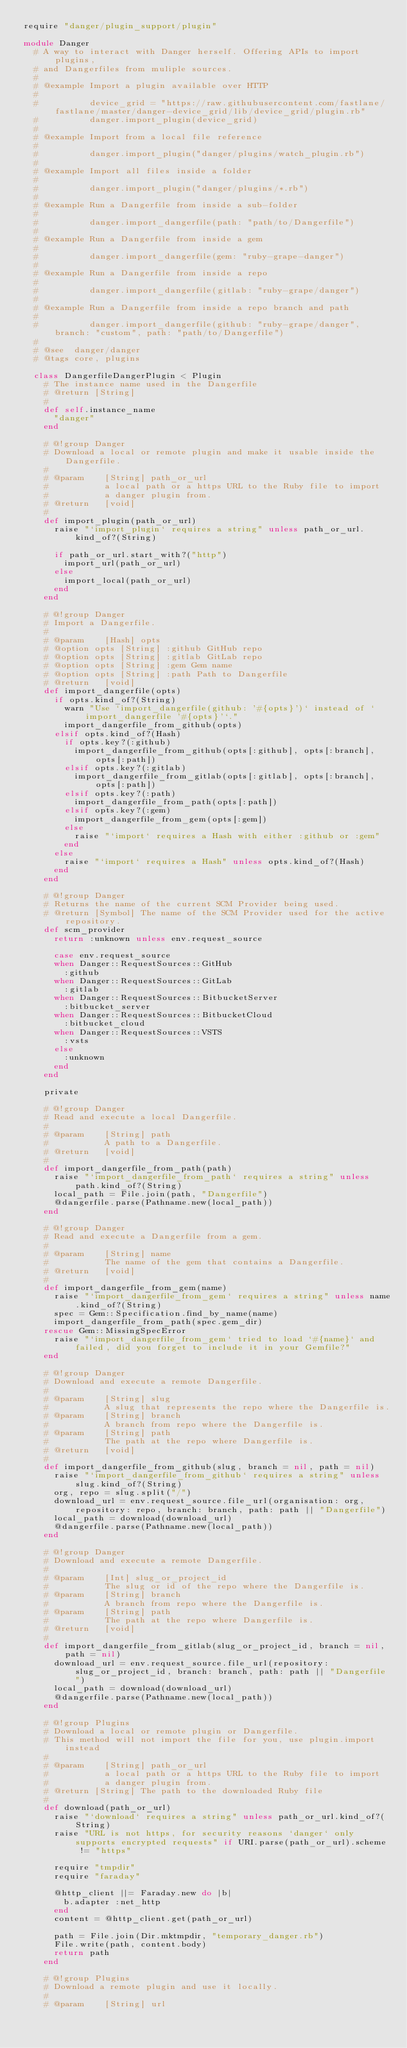Convert code to text. <code><loc_0><loc_0><loc_500><loc_500><_Ruby_>require "danger/plugin_support/plugin"

module Danger
  # A way to interact with Danger herself. Offering APIs to import plugins,
  # and Dangerfiles from muliple sources.
  #
  # @example Import a plugin available over HTTP
  #
  #          device_grid = "https://raw.githubusercontent.com/fastlane/fastlane/master/danger-device_grid/lib/device_grid/plugin.rb"
  #          danger.import_plugin(device_grid)
  #
  # @example Import from a local file reference
  #
  #          danger.import_plugin("danger/plugins/watch_plugin.rb")
  #
  # @example Import all files inside a folder
  #
  #          danger.import_plugin("danger/plugins/*.rb")
  #
  # @example Run a Dangerfile from inside a sub-folder
  #
  #          danger.import_dangerfile(path: "path/to/Dangerfile")
  #
  # @example Run a Dangerfile from inside a gem
  #
  #          danger.import_dangerfile(gem: "ruby-grape-danger")
  #
  # @example Run a Dangerfile from inside a repo
  #
  #          danger.import_dangerfile(gitlab: "ruby-grape/danger")
  #
  # @example Run a Dangerfile from inside a repo branch and path
  #
  #          danger.import_dangerfile(github: "ruby-grape/danger", branch: "custom", path: "path/to/Dangerfile")
  #
  # @see  danger/danger
  # @tags core, plugins

  class DangerfileDangerPlugin < Plugin
    # The instance name used in the Dangerfile
    # @return [String]
    #
    def self.instance_name
      "danger"
    end

    # @!group Danger
    # Download a local or remote plugin and make it usable inside the Dangerfile.
    #
    # @param    [String] path_or_url
    #           a local path or a https URL to the Ruby file to import
    #           a danger plugin from.
    # @return   [void]
    #
    def import_plugin(path_or_url)
      raise "`import_plugin` requires a string" unless path_or_url.kind_of?(String)

      if path_or_url.start_with?("http")
        import_url(path_or_url)
      else
        import_local(path_or_url)
      end
    end

    # @!group Danger
    # Import a Dangerfile.
    #
    # @param    [Hash] opts
    # @option opts [String] :github GitHub repo
    # @option opts [String] :gitlab GitLab repo
    # @option opts [String] :gem Gem name
    # @option opts [String] :path Path to Dangerfile
    # @return   [void]
    def import_dangerfile(opts)
      if opts.kind_of?(String)
        warn "Use `import_dangerfile(github: '#{opts}')` instead of `import_dangerfile '#{opts}'`."
        import_dangerfile_from_github(opts)
      elsif opts.kind_of?(Hash)
        if opts.key?(:github)
          import_dangerfile_from_github(opts[:github], opts[:branch], opts[:path])
        elsif opts.key?(:gitlab)
          import_dangerfile_from_gitlab(opts[:gitlab], opts[:branch], opts[:path])
        elsif opts.key?(:path)
          import_dangerfile_from_path(opts[:path])
        elsif opts.key?(:gem)
          import_dangerfile_from_gem(opts[:gem])
        else
          raise "`import` requires a Hash with either :github or :gem"
        end
      else
        raise "`import` requires a Hash" unless opts.kind_of?(Hash)
      end
    end

    # @!group Danger
    # Returns the name of the current SCM Provider being used.
    # @return [Symbol] The name of the SCM Provider used for the active repository.
    def scm_provider
      return :unknown unless env.request_source

      case env.request_source
      when Danger::RequestSources::GitHub
        :github
      when Danger::RequestSources::GitLab
        :gitlab
      when Danger::RequestSources::BitbucketServer
        :bitbucket_server
      when Danger::RequestSources::BitbucketCloud
        :bitbucket_cloud
      when Danger::RequestSources::VSTS
        :vsts
      else
        :unknown
      end
    end

    private

    # @!group Danger
    # Read and execute a local Dangerfile.
    #
    # @param    [String] path
    #           A path to a Dangerfile.
    # @return   [void]
    #
    def import_dangerfile_from_path(path)
      raise "`import_dangerfile_from_path` requires a string" unless path.kind_of?(String)
      local_path = File.join(path, "Dangerfile")
      @dangerfile.parse(Pathname.new(local_path))
    end

    # @!group Danger
    # Read and execute a Dangerfile from a gem.
    #
    # @param    [String] name
    #           The name of the gem that contains a Dangerfile.
    # @return   [void]
    #
    def import_dangerfile_from_gem(name)
      raise "`import_dangerfile_from_gem` requires a string" unless name.kind_of?(String)
      spec = Gem::Specification.find_by_name(name)
      import_dangerfile_from_path(spec.gem_dir)
    rescue Gem::MissingSpecError
      raise "`import_dangerfile_from_gem` tried to load `#{name}` and failed, did you forget to include it in your Gemfile?"
    end

    # @!group Danger
    # Download and execute a remote Dangerfile.
    #
    # @param    [String] slug
    #           A slug that represents the repo where the Dangerfile is.
    # @param    [String] branch
    #           A branch from repo where the Dangerfile is.
    # @param    [String] path
    #           The path at the repo where Dangerfile is.
    # @return   [void]
    #
    def import_dangerfile_from_github(slug, branch = nil, path = nil)
      raise "`import_dangerfile_from_github` requires a string" unless slug.kind_of?(String)
      org, repo = slug.split("/")
      download_url = env.request_source.file_url(organisation: org, repository: repo, branch: branch, path: path || "Dangerfile")
      local_path = download(download_url)
      @dangerfile.parse(Pathname.new(local_path))
    end

    # @!group Danger
    # Download and execute a remote Dangerfile.
    #
    # @param    [Int] slug_or_project_id
    #           The slug or id of the repo where the Dangerfile is.
    # @param    [String] branch
    #           A branch from repo where the Dangerfile is.
    # @param    [String] path
    #           The path at the repo where Dangerfile is.
    # @return   [void]
    #
    def import_dangerfile_from_gitlab(slug_or_project_id, branch = nil, path = nil)
      download_url = env.request_source.file_url(repository: slug_or_project_id, branch: branch, path: path || "Dangerfile")
      local_path = download(download_url)
      @dangerfile.parse(Pathname.new(local_path))
    end

    # @!group Plugins
    # Download a local or remote plugin or Dangerfile.
    # This method will not import the file for you, use plugin.import instead
    #
    # @param    [String] path_or_url
    #           a local path or a https URL to the Ruby file to import
    #           a danger plugin from.
    # @return [String] The path to the downloaded Ruby file
    #
    def download(path_or_url)
      raise "`download` requires a string" unless path_or_url.kind_of?(String)
      raise "URL is not https, for security reasons `danger` only supports encrypted requests" if URI.parse(path_or_url).scheme != "https"

      require "tmpdir"
      require "faraday"

      @http_client ||= Faraday.new do |b|
        b.adapter :net_http
      end
      content = @http_client.get(path_or_url)

      path = File.join(Dir.mktmpdir, "temporary_danger.rb")
      File.write(path, content.body)
      return path
    end

    # @!group Plugins
    # Download a remote plugin and use it locally.
    #
    # @param    [String] url</code> 